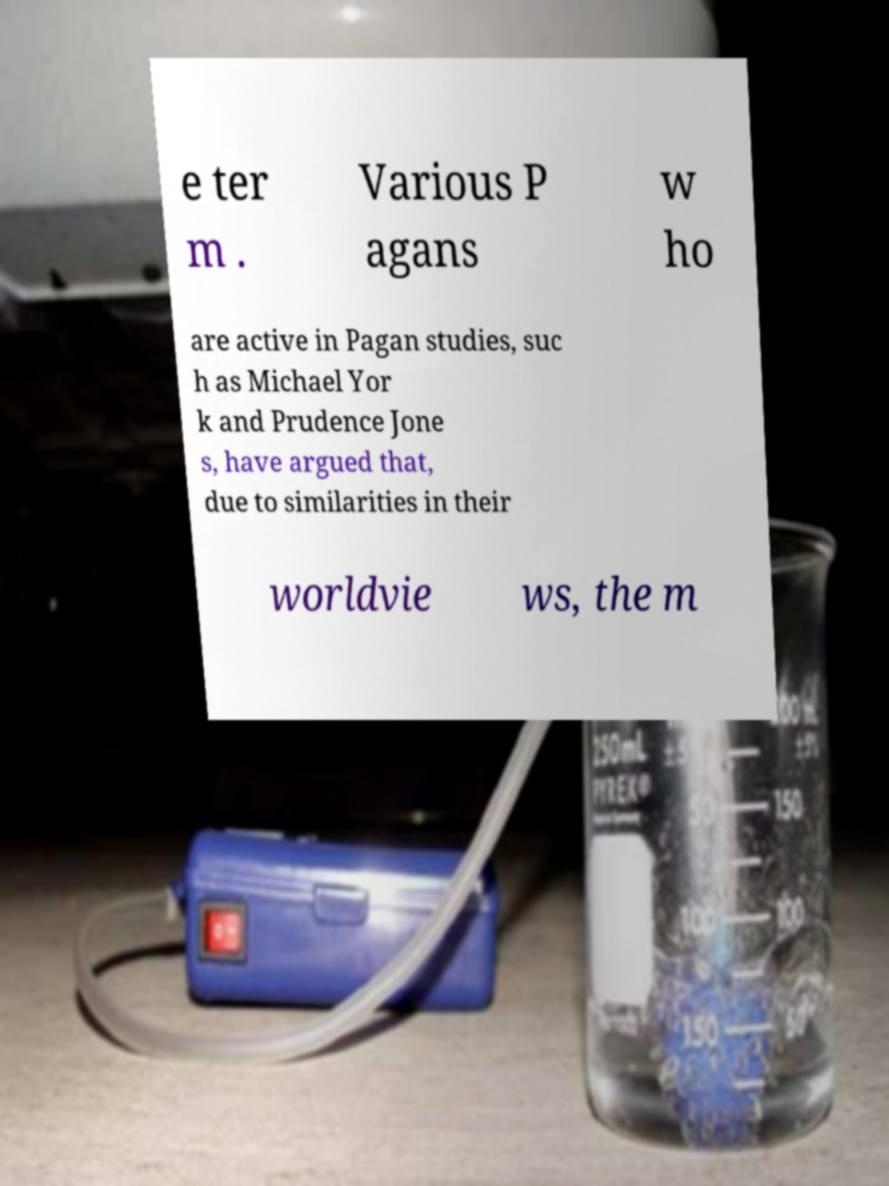I need the written content from this picture converted into text. Can you do that? e ter m . Various P agans w ho are active in Pagan studies, suc h as Michael Yor k and Prudence Jone s, have argued that, due to similarities in their worldvie ws, the m 